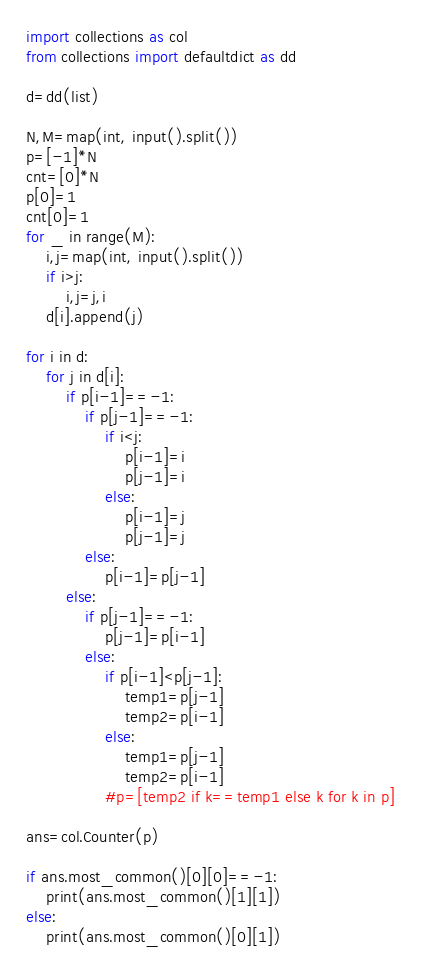<code> <loc_0><loc_0><loc_500><loc_500><_Python_>import collections as col
from collections import defaultdict as dd

d=dd(list)

N,M=map(int, input().split())
p=[-1]*N
cnt=[0]*N
p[0]=1
cnt[0]=1
for _ in range(M):
    i,j=map(int, input().split())
    if i>j:
        i,j=j,i
    d[i].append(j)

for i in d:
    for j in d[i]:
        if p[i-1]==-1:
            if p[j-1]==-1:
                if i<j:
                    p[i-1]=i
                    p[j-1]=i
                else:
                    p[i-1]=j
                    p[j-1]=j
            else:
                p[i-1]=p[j-1]
        else:
            if p[j-1]==-1:
                p[j-1]=p[i-1]
            else:
                if p[i-1]<p[j-1]:
                    temp1=p[j-1]
                    temp2=p[i-1]
                else:
                    temp1=p[j-1]
                    temp2=p[i-1]
                #p=[temp2 if k==temp1 else k for k in p]

ans=col.Counter(p)

if ans.most_common()[0][0]==-1:
    print(ans.most_common()[1][1])
else:
    print(ans.most_common()[0][1])</code> 